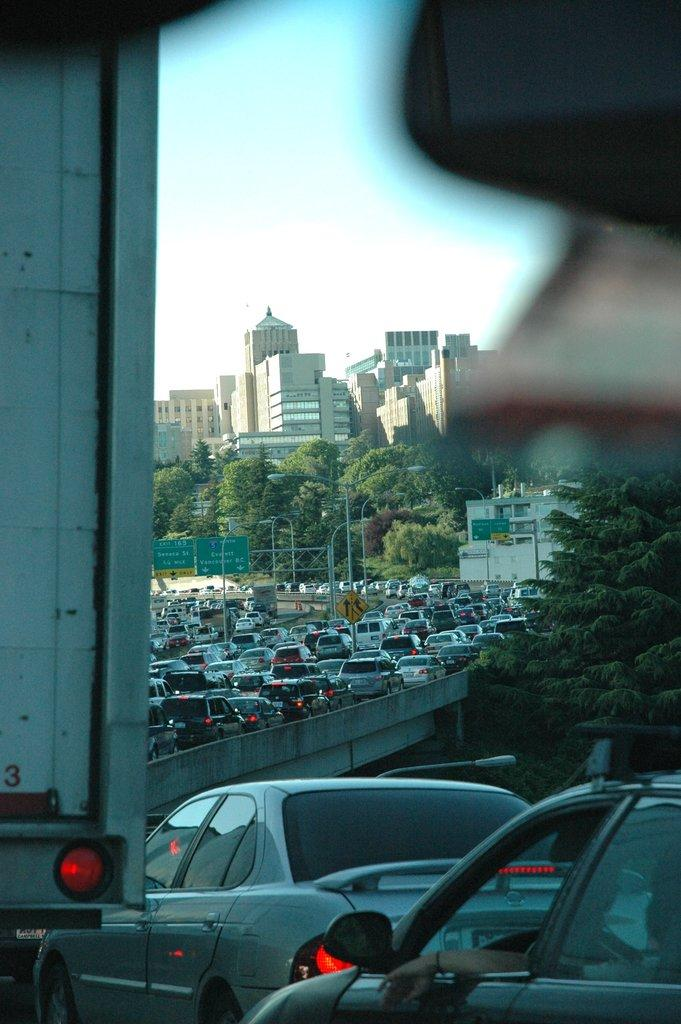What can be seen on the flyover in the image? There are vehicles on the flyover in the image. What objects are present in the image besides the vehicles? There are boards, poles, lights, trees, and buildings in the image. What is visible in the background of the image? The sky is visible in the background of the image. What type of wax is being used to create the knowledge in the image? There is no wax or knowledge present in the image; it features vehicles on a flyover, boards, poles, lights, trees, buildings, and the sky. 